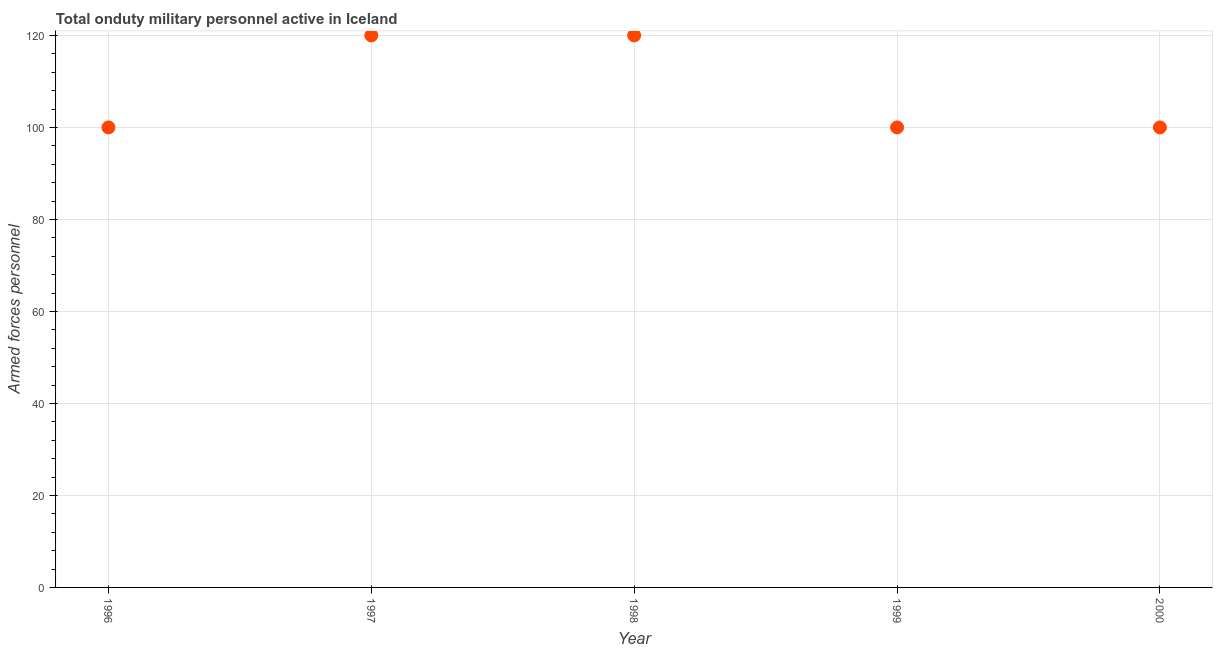What is the number of armed forces personnel in 1997?
Give a very brief answer. 120. Across all years, what is the maximum number of armed forces personnel?
Keep it short and to the point. 120. Across all years, what is the minimum number of armed forces personnel?
Your answer should be very brief. 100. In which year was the number of armed forces personnel maximum?
Ensure brevity in your answer.  1997. In which year was the number of armed forces personnel minimum?
Give a very brief answer. 1996. What is the sum of the number of armed forces personnel?
Your answer should be very brief. 540. What is the difference between the number of armed forces personnel in 1996 and 1997?
Provide a succinct answer. -20. What is the average number of armed forces personnel per year?
Offer a terse response. 108. Is the number of armed forces personnel in 1996 less than that in 1997?
Your response must be concise. Yes. What is the difference between the highest and the second highest number of armed forces personnel?
Keep it short and to the point. 0. What is the difference between the highest and the lowest number of armed forces personnel?
Your answer should be very brief. 20. In how many years, is the number of armed forces personnel greater than the average number of armed forces personnel taken over all years?
Give a very brief answer. 2. How many years are there in the graph?
Offer a terse response. 5. What is the difference between two consecutive major ticks on the Y-axis?
Your answer should be compact. 20. Does the graph contain any zero values?
Offer a very short reply. No. Does the graph contain grids?
Your response must be concise. Yes. What is the title of the graph?
Offer a terse response. Total onduty military personnel active in Iceland. What is the label or title of the X-axis?
Your answer should be very brief. Year. What is the label or title of the Y-axis?
Give a very brief answer. Armed forces personnel. What is the Armed forces personnel in 1997?
Give a very brief answer. 120. What is the Armed forces personnel in 1998?
Offer a terse response. 120. What is the Armed forces personnel in 1999?
Ensure brevity in your answer.  100. What is the Armed forces personnel in 2000?
Your answer should be compact. 100. What is the difference between the Armed forces personnel in 1996 and 1999?
Provide a short and direct response. 0. What is the difference between the Armed forces personnel in 1998 and 1999?
Give a very brief answer. 20. What is the difference between the Armed forces personnel in 1998 and 2000?
Give a very brief answer. 20. What is the difference between the Armed forces personnel in 1999 and 2000?
Make the answer very short. 0. What is the ratio of the Armed forces personnel in 1996 to that in 1997?
Make the answer very short. 0.83. What is the ratio of the Armed forces personnel in 1996 to that in 1998?
Offer a terse response. 0.83. What is the ratio of the Armed forces personnel in 1997 to that in 1998?
Your answer should be compact. 1. What is the ratio of the Armed forces personnel in 1997 to that in 1999?
Keep it short and to the point. 1.2. What is the ratio of the Armed forces personnel in 1997 to that in 2000?
Give a very brief answer. 1.2. What is the ratio of the Armed forces personnel in 1998 to that in 2000?
Offer a very short reply. 1.2. 